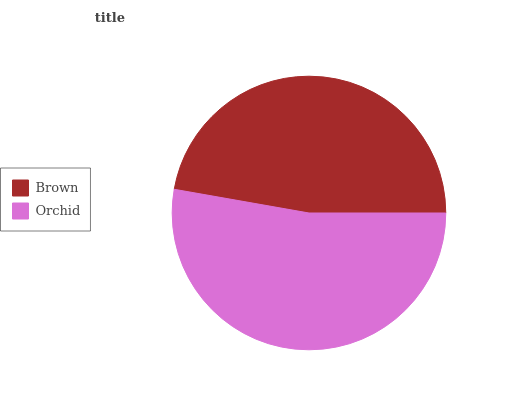Is Brown the minimum?
Answer yes or no. Yes. Is Orchid the maximum?
Answer yes or no. Yes. Is Orchid the minimum?
Answer yes or no. No. Is Orchid greater than Brown?
Answer yes or no. Yes. Is Brown less than Orchid?
Answer yes or no. Yes. Is Brown greater than Orchid?
Answer yes or no. No. Is Orchid less than Brown?
Answer yes or no. No. Is Orchid the high median?
Answer yes or no. Yes. Is Brown the low median?
Answer yes or no. Yes. Is Brown the high median?
Answer yes or no. No. Is Orchid the low median?
Answer yes or no. No. 